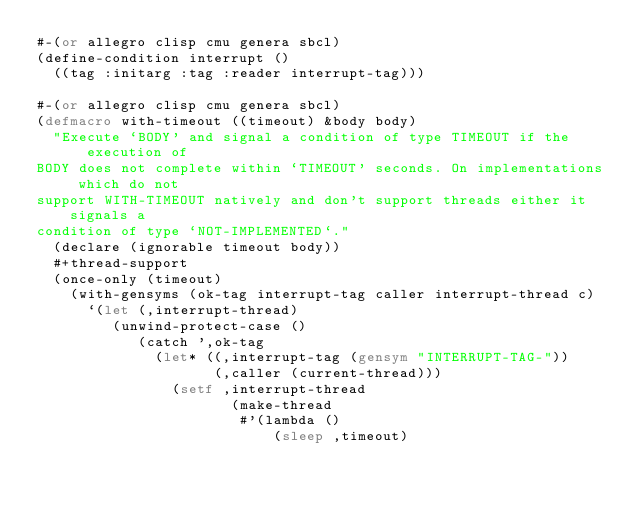<code> <loc_0><loc_0><loc_500><loc_500><_Lisp_>#-(or allegro clisp cmu genera sbcl)
(define-condition interrupt ()
  ((tag :initarg :tag :reader interrupt-tag)))

#-(or allegro clisp cmu genera sbcl)
(defmacro with-timeout ((timeout) &body body)
  "Execute `BODY' and signal a condition of type TIMEOUT if the execution of
BODY does not complete within `TIMEOUT' seconds. On implementations which do not
support WITH-TIMEOUT natively and don't support threads either it signals a
condition of type `NOT-IMPLEMENTED`."
  (declare (ignorable timeout body))
  #+thread-support
  (once-only (timeout)
    (with-gensyms (ok-tag interrupt-tag caller interrupt-thread c)
      `(let (,interrupt-thread)
         (unwind-protect-case ()
            (catch ',ok-tag
              (let* ((,interrupt-tag (gensym "INTERRUPT-TAG-"))
                     (,caller (current-thread)))
                (setf ,interrupt-thread
                       (make-thread
                        #'(lambda ()
                            (sleep ,timeout)</code> 